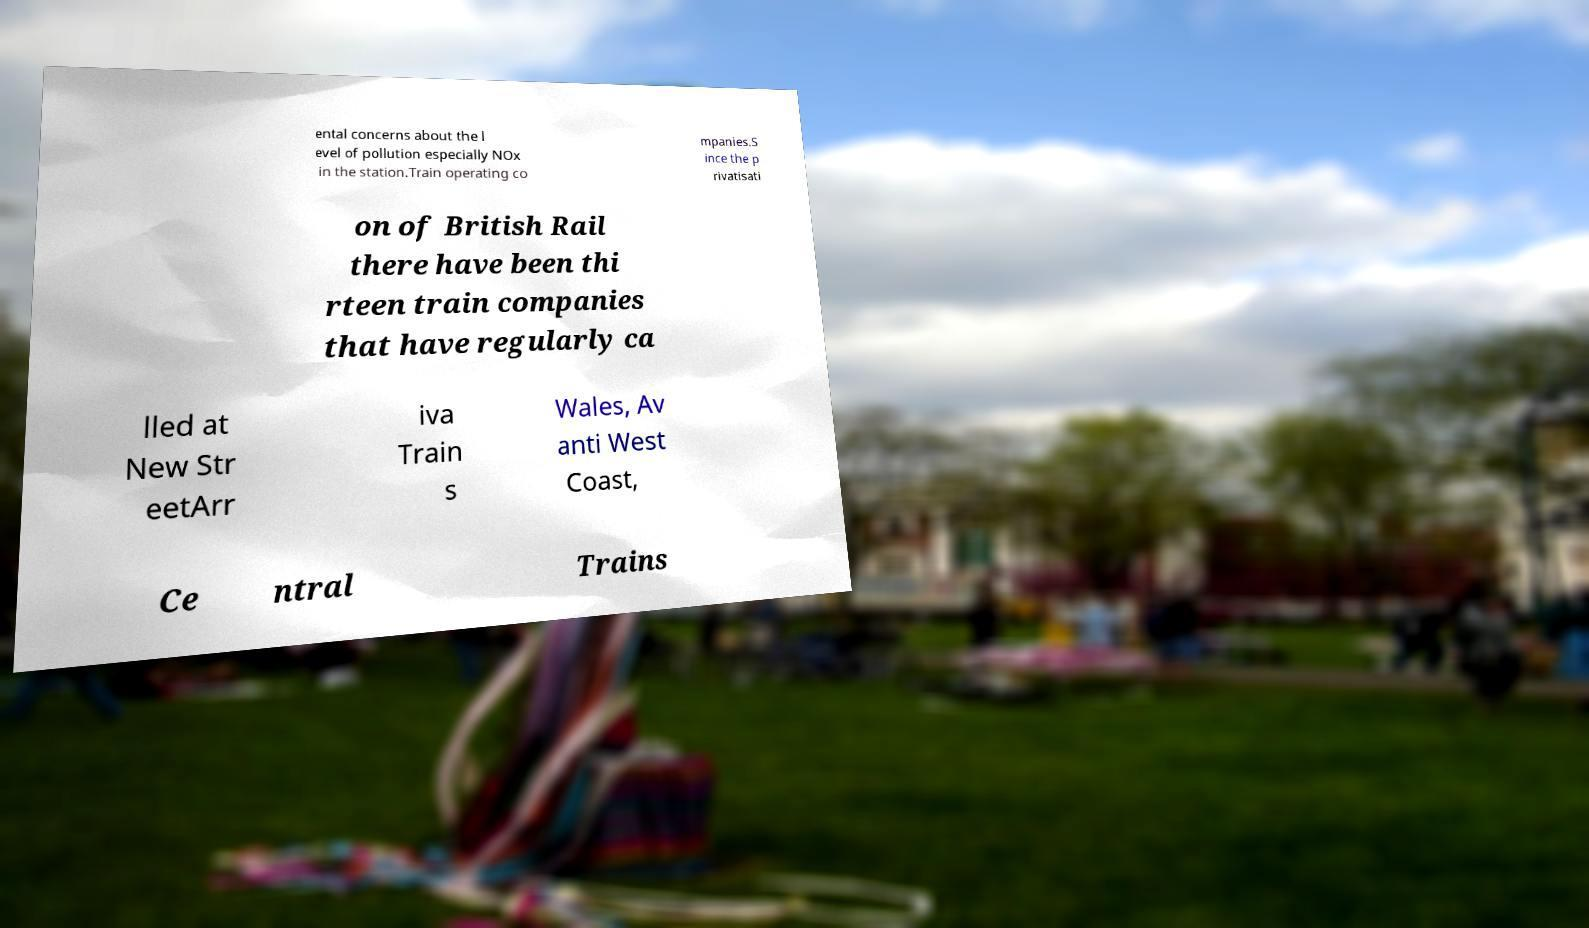Please read and relay the text visible in this image. What does it say? ental concerns about the l evel of pollution especially NOx in the station.Train operating co mpanies.S ince the p rivatisati on of British Rail there have been thi rteen train companies that have regularly ca lled at New Str eetArr iva Train s Wales, Av anti West Coast, Ce ntral Trains 